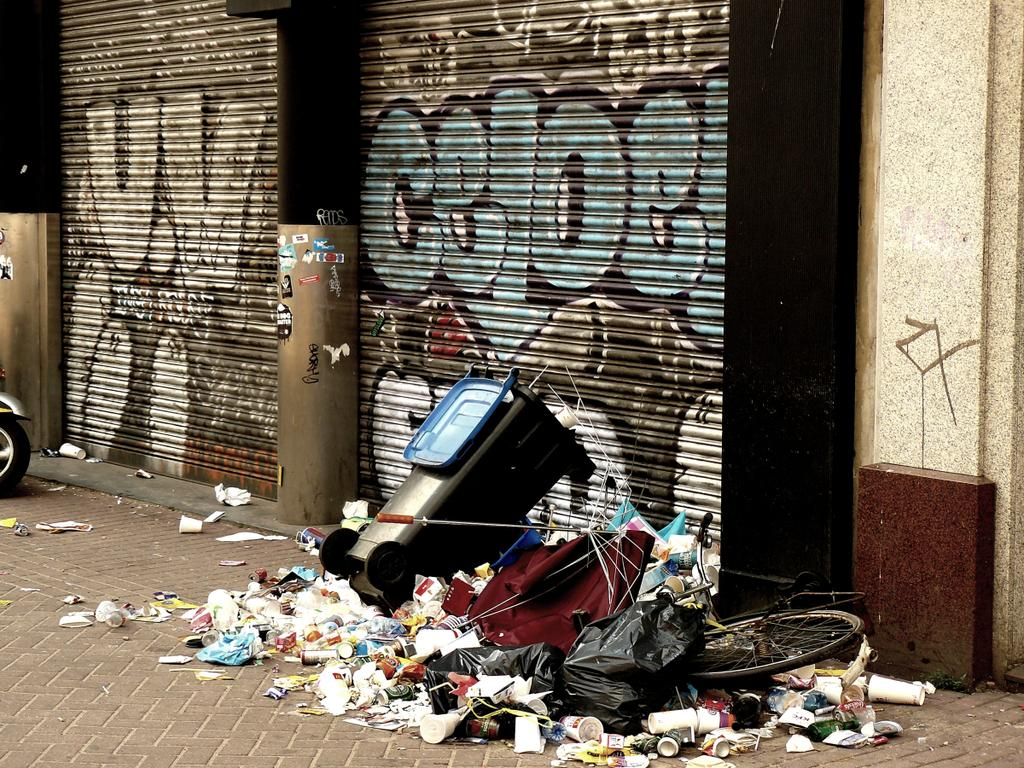<image>
Share a concise interpretation of the image provided. A street with lots of garbage and graffiti reading CELOE on the garage door. 